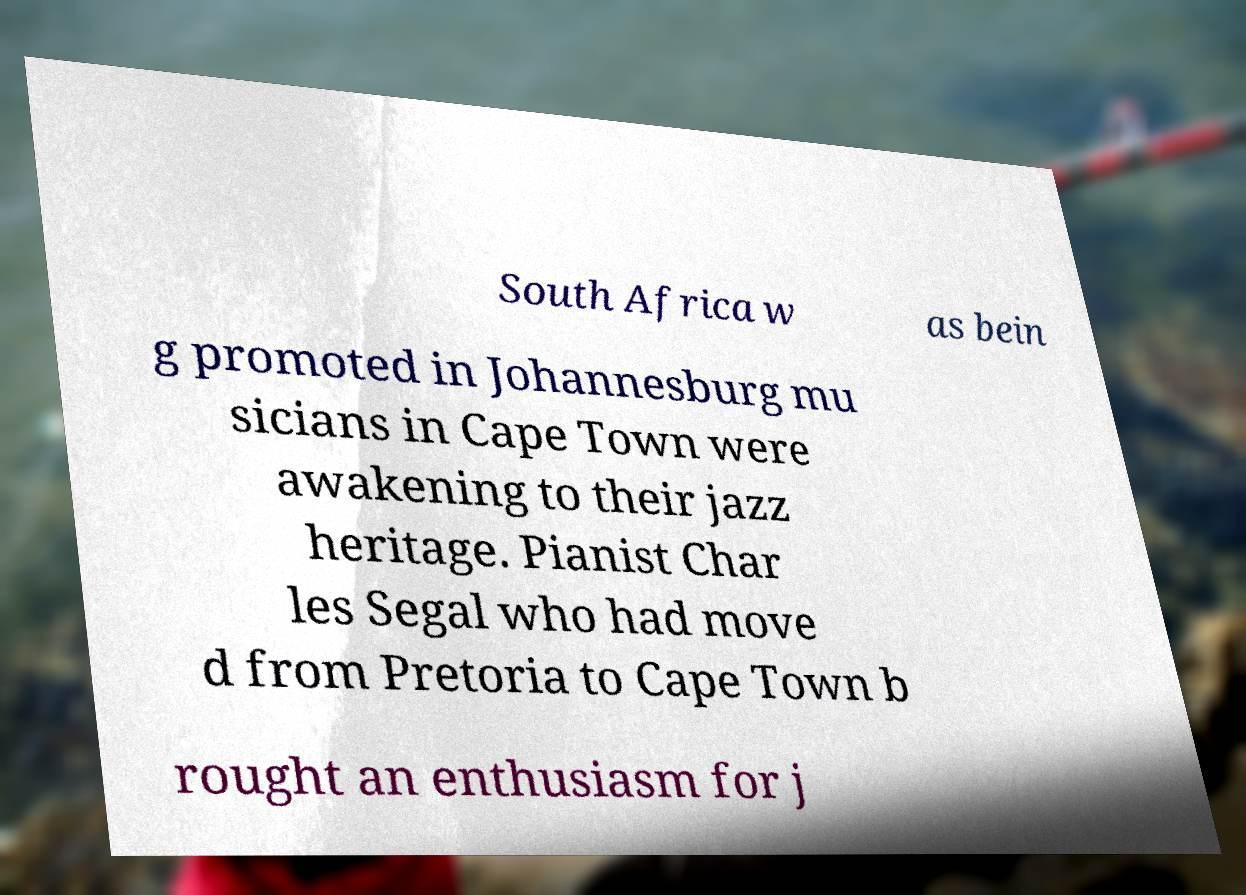I need the written content from this picture converted into text. Can you do that? South Africa w as bein g promoted in Johannesburg mu sicians in Cape Town were awakening to their jazz heritage. Pianist Char les Segal who had move d from Pretoria to Cape Town b rought an enthusiasm for j 